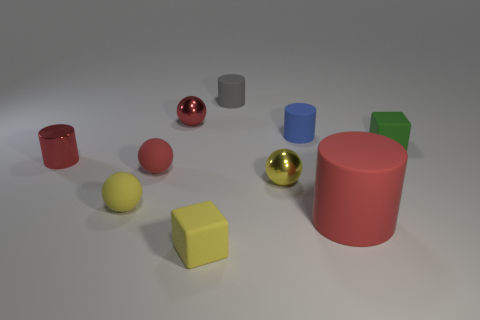Subtract all yellow spheres. How many were subtracted if there are1yellow spheres left? 1 Subtract 2 cylinders. How many cylinders are left? 2 Subtract all cyan cylinders. Subtract all purple cubes. How many cylinders are left? 4 Subtract all cylinders. How many objects are left? 6 Subtract 0 blue blocks. How many objects are left? 10 Subtract all brown cylinders. Subtract all green rubber cubes. How many objects are left? 9 Add 2 yellow metal balls. How many yellow metal balls are left? 3 Add 9 tiny yellow cubes. How many tiny yellow cubes exist? 10 